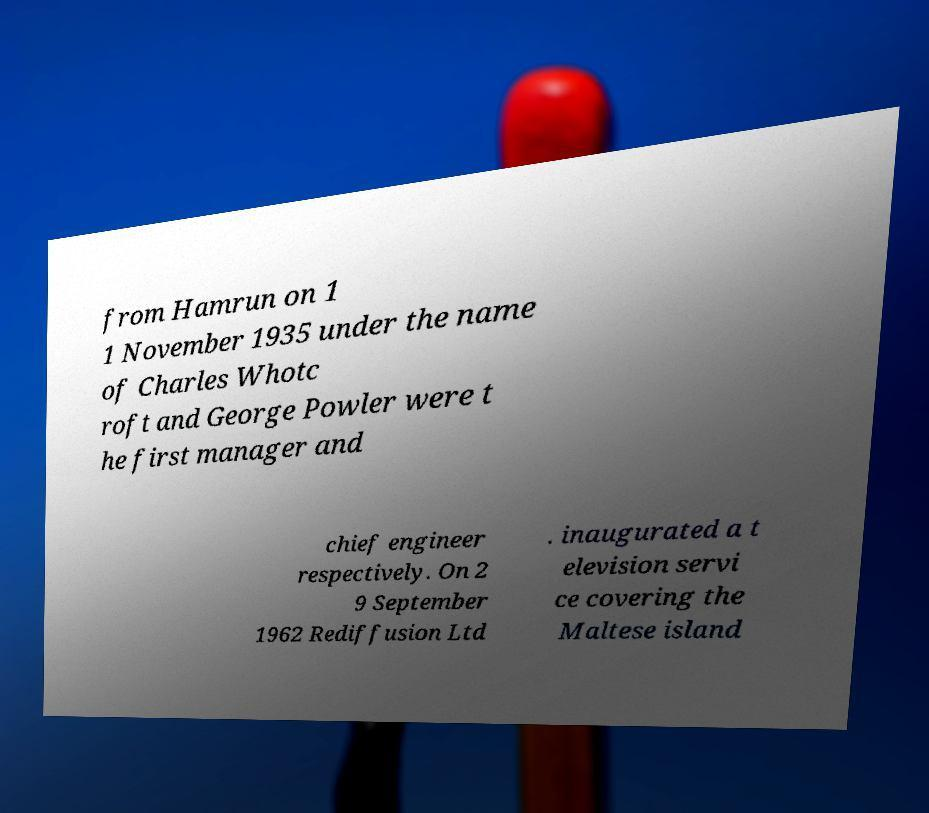Can you read and provide the text displayed in the image?This photo seems to have some interesting text. Can you extract and type it out for me? from Hamrun on 1 1 November 1935 under the name of Charles Whotc roft and George Powler were t he first manager and chief engineer respectively. On 2 9 September 1962 Rediffusion Ltd . inaugurated a t elevision servi ce covering the Maltese island 